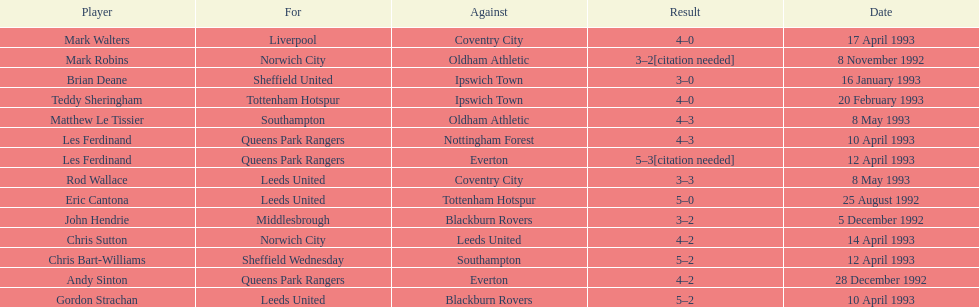In the 1992-1993 premier league, what was the total number of hat tricks scored by all players? 14. 